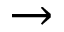Convert formula to latex. <formula><loc_0><loc_0><loc_500><loc_500>\rightarrow</formula> 